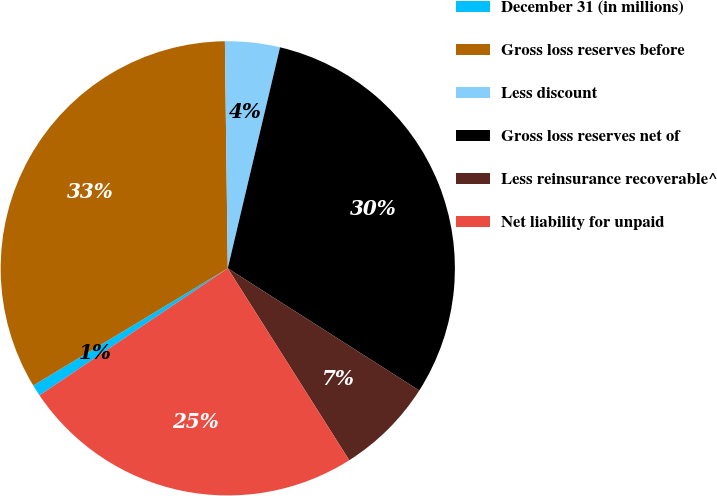<chart> <loc_0><loc_0><loc_500><loc_500><pie_chart><fcel>December 31 (in millions)<fcel>Gross loss reserves before<fcel>Less discount<fcel>Gross loss reserves net of<fcel>Less reinsurance recoverable^<fcel>Net liability for unpaid<nl><fcel>0.82%<fcel>33.43%<fcel>3.9%<fcel>30.35%<fcel>6.98%<fcel>24.54%<nl></chart> 